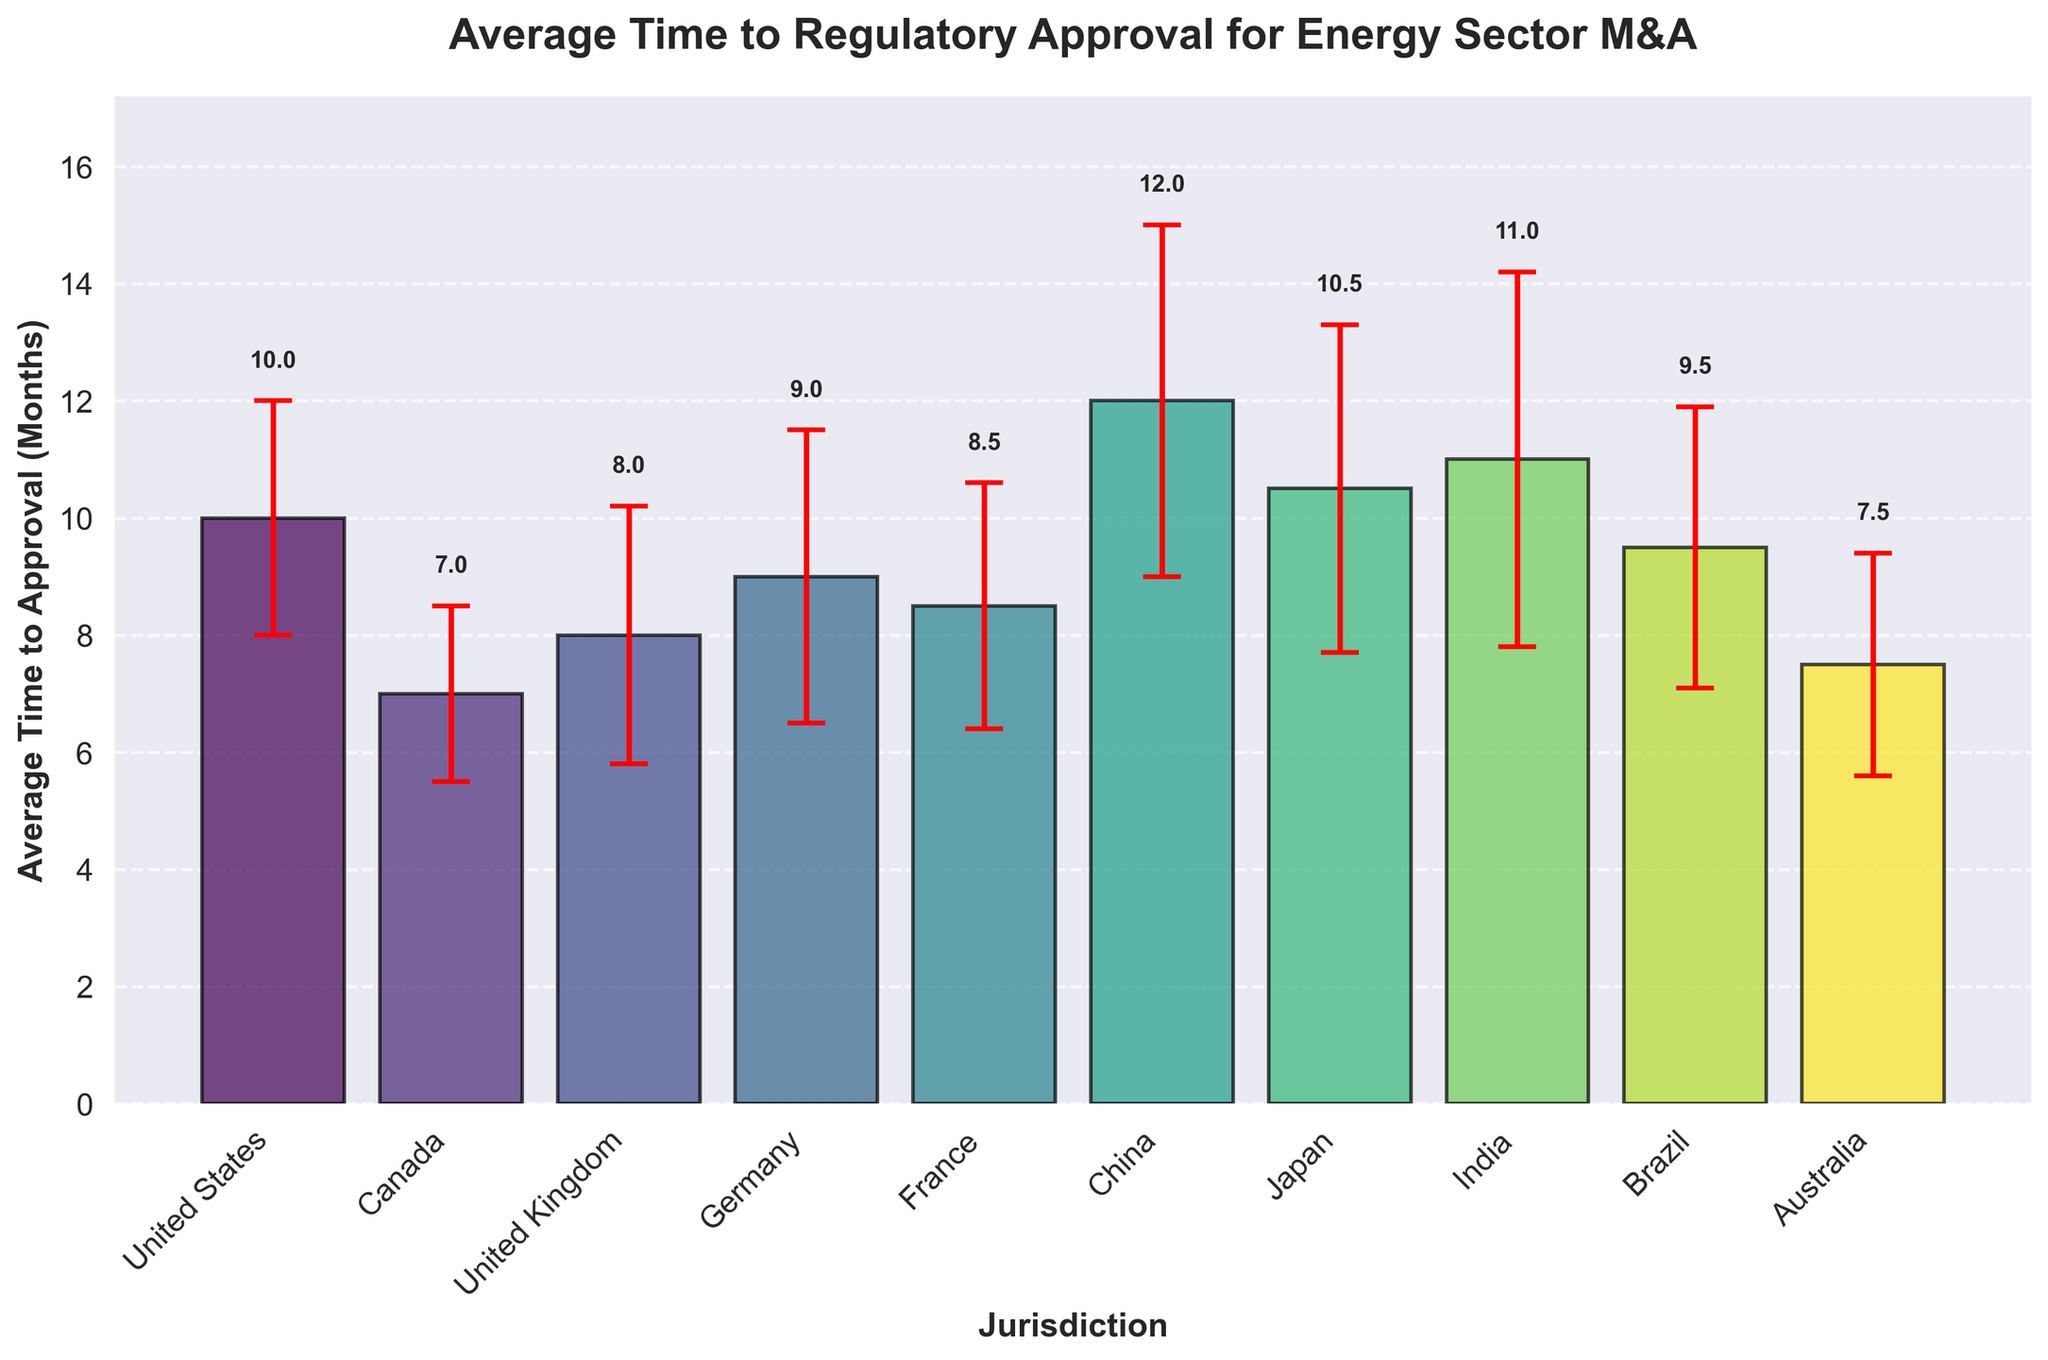What is the jurisdiction with the longest average time to regulatory approval? To find the jurisdiction with the longest average time to regulatory approval, look for the highest bar in the plot. The jurisdiction with the highest bar is China, with 12 months.
Answer: China What is the average time to regulatory approval in Canada? Locate the bar representing Canada on the x-axis and refer to its height. The height represents the average time, which is 7 months.
Answer: 7 months Which jurisdiction has the smallest standard deviation for the average time to regulatory approval? Examine the error bars indicating standard deviation. The smallest error bar belongs to Canada, with a standard deviation of 1.5 months.
Answer: Canada How many jurisdictions have an average time to regulatory approval greater than 10 months? Identify the bars with heights greater than 10. These are for China, Japan, and India. There are 3 jurisdictions.
Answer: 3 What is the difference in average time to regulatory approval between the United States and Australia? Subtract the average time for Australia from that for the United States. The difference is 10 - 7.5 = 2.5 months.
Answer: 2.5 months How does the average time to regulatory approval in France compare to that in Germany? Compare the heights of the bars for France and Germany. France averages 8.5 months, while Germany averages 9 months. France has a shorter average time.
Answer: France has a shorter average time What is the combined standard deviation for the United Kingdom and Germany? Add the standard deviations for the United Kingdom (2.2) and Germany (2.5). The combined standard deviation is 2.2 + 2.5 = 4.7 months.
Answer: 4.7 months Which jurisdictions have error bars extending beyond 11 months for some data points? Identify the bars whose top error bar exceeds 11 months. These jurisdictions are China and India.
Answer: China and India What is the total standard deviation for all jurisdictions? Sum the standard deviations for all jurisdictions: 2 + 1.5 + 2.2 + 2.5 + 2.1 + 3 + 2.8 + 3.2 + 2.4 + 1.9 = 24.6 months.
Answer: 24.6 months 